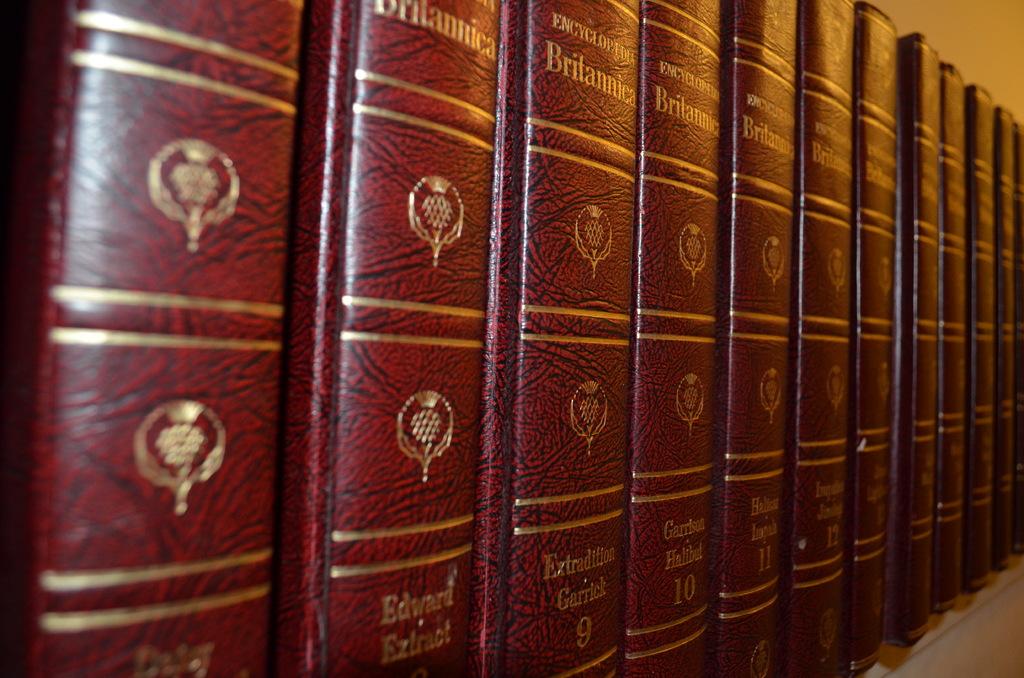What kind of encyclopedia is this?
Ensure brevity in your answer.  Britannica. 